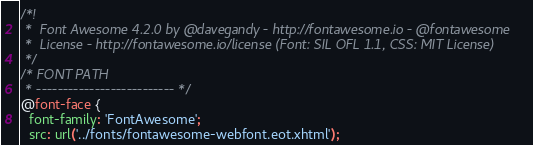Convert code to text. <code><loc_0><loc_0><loc_500><loc_500><_CSS_>/*!
 *  Font Awesome 4.2.0 by @davegandy - http://fontawesome.io - @fontawesome
 *  License - http://fontawesome.io/license (Font: SIL OFL 1.1, CSS: MIT License)
 */
/* FONT PATH
 * -------------------------- */
@font-face {
  font-family: 'FontAwesome';
  src: url('../fonts/fontawesome-webfont.eot.xhtml');</code> 